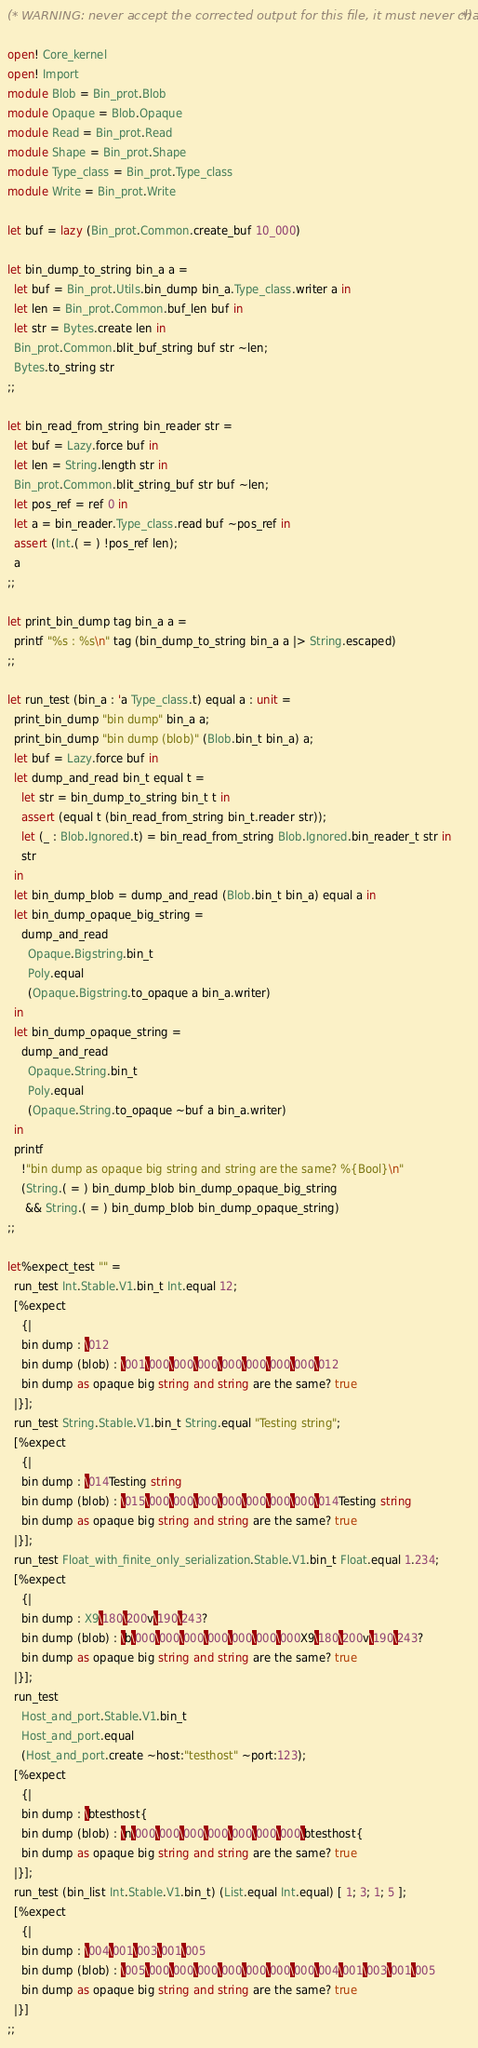Convert code to text. <code><loc_0><loc_0><loc_500><loc_500><_OCaml_>(* WARNING: never accept the corrected output for this file, it must never change! *)

open! Core_kernel
open! Import
module Blob = Bin_prot.Blob
module Opaque = Blob.Opaque
module Read = Bin_prot.Read
module Shape = Bin_prot.Shape
module Type_class = Bin_prot.Type_class
module Write = Bin_prot.Write

let buf = lazy (Bin_prot.Common.create_buf 10_000)

let bin_dump_to_string bin_a a =
  let buf = Bin_prot.Utils.bin_dump bin_a.Type_class.writer a in
  let len = Bin_prot.Common.buf_len buf in
  let str = Bytes.create len in
  Bin_prot.Common.blit_buf_string buf str ~len;
  Bytes.to_string str
;;

let bin_read_from_string bin_reader str =
  let buf = Lazy.force buf in
  let len = String.length str in
  Bin_prot.Common.blit_string_buf str buf ~len;
  let pos_ref = ref 0 in
  let a = bin_reader.Type_class.read buf ~pos_ref in
  assert (Int.( = ) !pos_ref len);
  a
;;

let print_bin_dump tag bin_a a =
  printf "%s : %s\n" tag (bin_dump_to_string bin_a a |> String.escaped)
;;

let run_test (bin_a : 'a Type_class.t) equal a : unit =
  print_bin_dump "bin dump" bin_a a;
  print_bin_dump "bin dump (blob)" (Blob.bin_t bin_a) a;
  let buf = Lazy.force buf in
  let dump_and_read bin_t equal t =
    let str = bin_dump_to_string bin_t t in
    assert (equal t (bin_read_from_string bin_t.reader str));
    let (_ : Blob.Ignored.t) = bin_read_from_string Blob.Ignored.bin_reader_t str in
    str
  in
  let bin_dump_blob = dump_and_read (Blob.bin_t bin_a) equal a in
  let bin_dump_opaque_big_string =
    dump_and_read
      Opaque.Bigstring.bin_t
      Poly.equal
      (Opaque.Bigstring.to_opaque a bin_a.writer)
  in
  let bin_dump_opaque_string =
    dump_and_read
      Opaque.String.bin_t
      Poly.equal
      (Opaque.String.to_opaque ~buf a bin_a.writer)
  in
  printf
    !"bin dump as opaque big string and string are the same? %{Bool}\n"
    (String.( = ) bin_dump_blob bin_dump_opaque_big_string
     && String.( = ) bin_dump_blob bin_dump_opaque_string)
;;

let%expect_test "" =
  run_test Int.Stable.V1.bin_t Int.equal 12;
  [%expect
    {|
    bin dump : \012
    bin dump (blob) : \001\000\000\000\000\000\000\000\012
    bin dump as opaque big string and string are the same? true
  |}];
  run_test String.Stable.V1.bin_t String.equal "Testing string";
  [%expect
    {|
    bin dump : \014Testing string
    bin dump (blob) : \015\000\000\000\000\000\000\000\014Testing string
    bin dump as opaque big string and string are the same? true
  |}];
  run_test Float_with_finite_only_serialization.Stable.V1.bin_t Float.equal 1.234;
  [%expect
    {|
    bin dump : X9\180\200v\190\243?
    bin dump (blob) : \b\000\000\000\000\000\000\000X9\180\200v\190\243?
    bin dump as opaque big string and string are the same? true
  |}];
  run_test
    Host_and_port.Stable.V1.bin_t
    Host_and_port.equal
    (Host_and_port.create ~host:"testhost" ~port:123);
  [%expect
    {|
    bin dump : \btesthost{
    bin dump (blob) : \n\000\000\000\000\000\000\000\btesthost{
    bin dump as opaque big string and string are the same? true
  |}];
  run_test (bin_list Int.Stable.V1.bin_t) (List.equal Int.equal) [ 1; 3; 1; 5 ];
  [%expect
    {|
    bin dump : \004\001\003\001\005
    bin dump (blob) : \005\000\000\000\000\000\000\000\004\001\003\001\005
    bin dump as opaque big string and string are the same? true
  |}]
;;
</code> 